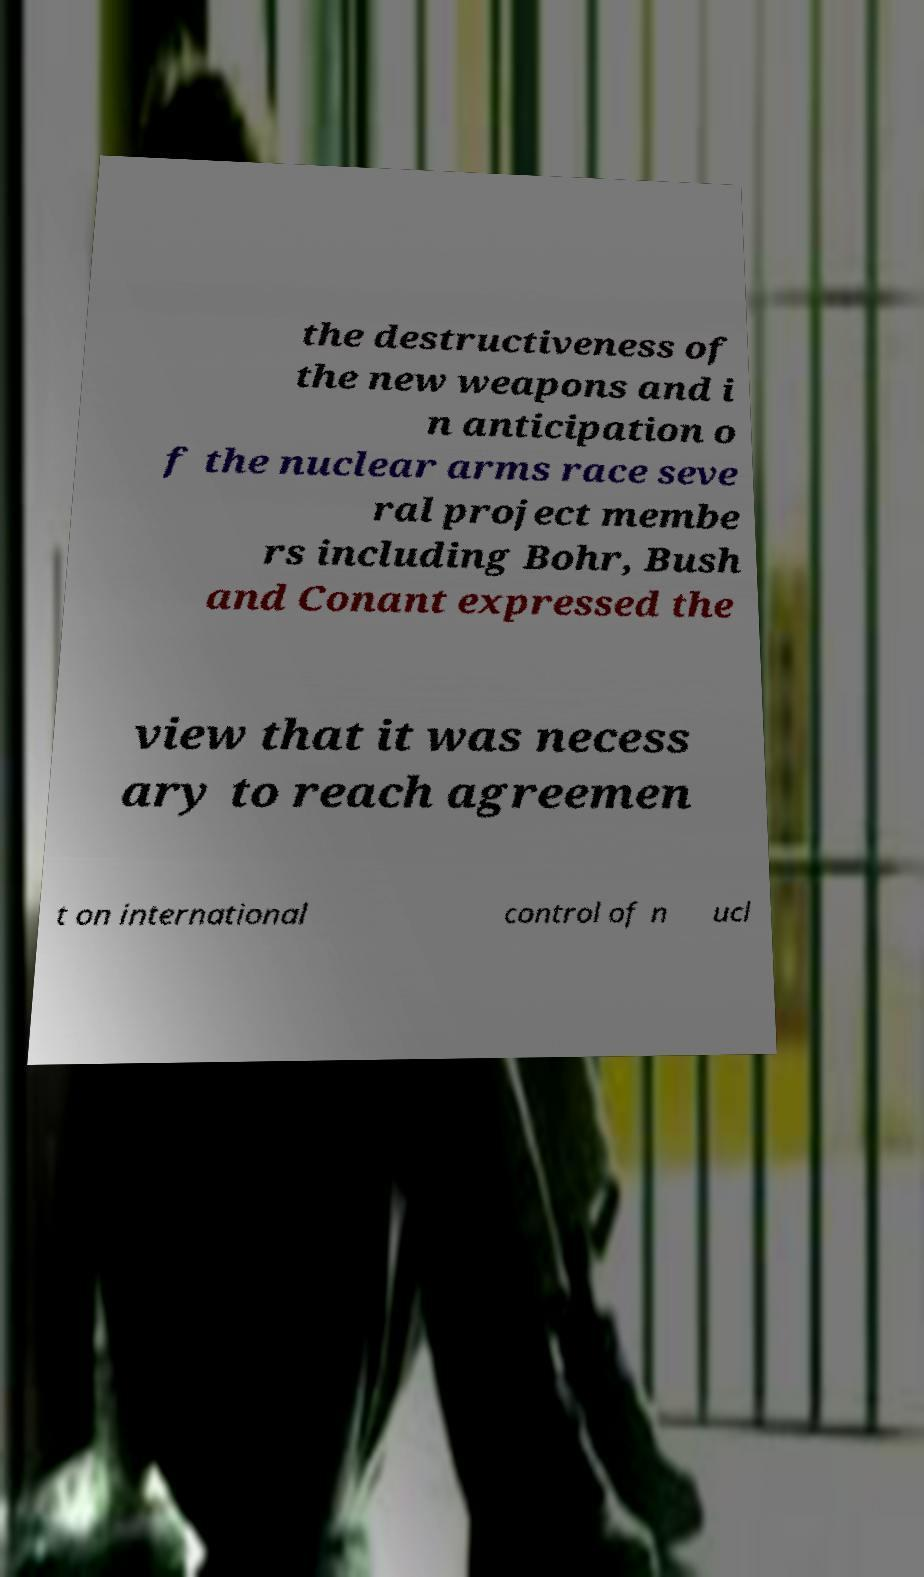Can you read and provide the text displayed in the image?This photo seems to have some interesting text. Can you extract and type it out for me? the destructiveness of the new weapons and i n anticipation o f the nuclear arms race seve ral project membe rs including Bohr, Bush and Conant expressed the view that it was necess ary to reach agreemen t on international control of n ucl 